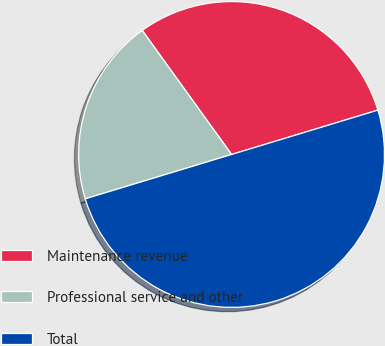Convert chart. <chart><loc_0><loc_0><loc_500><loc_500><pie_chart><fcel>Maintenance revenue<fcel>Professional service and other<fcel>Total<nl><fcel>30.25%<fcel>19.75%<fcel>50.0%<nl></chart> 